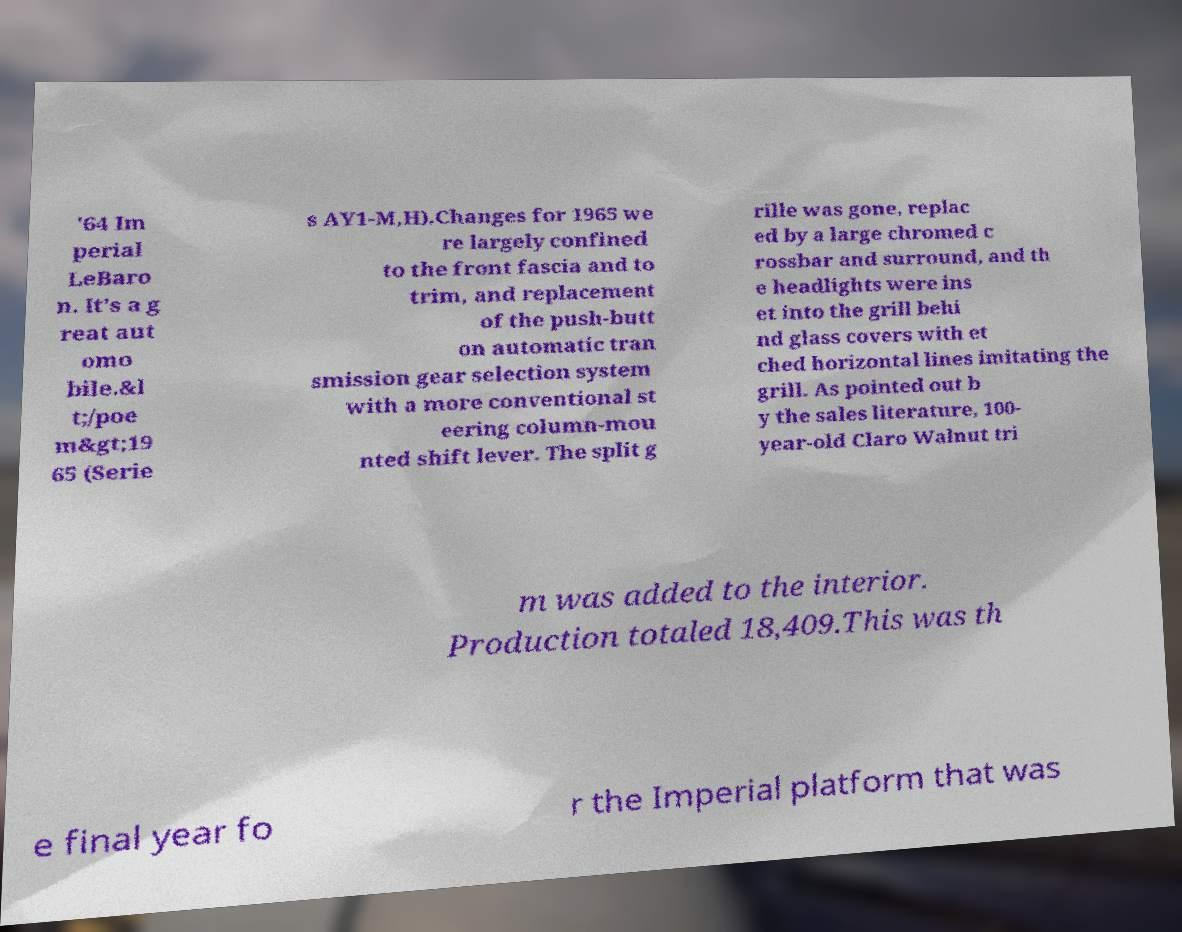There's text embedded in this image that I need extracted. Can you transcribe it verbatim? '64 Im perial LeBaro n. It's a g reat aut omo bile.&l t;/poe m&gt;19 65 (Serie s AY1-M,H).Changes for 1965 we re largely confined to the front fascia and to trim, and replacement of the push-butt on automatic tran smission gear selection system with a more conventional st eering column-mou nted shift lever. The split g rille was gone, replac ed by a large chromed c rossbar and surround, and th e headlights were ins et into the grill behi nd glass covers with et ched horizontal lines imitating the grill. As pointed out b y the sales literature, 100- year-old Claro Walnut tri m was added to the interior. Production totaled 18,409.This was th e final year fo r the Imperial platform that was 